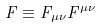Convert formula to latex. <formula><loc_0><loc_0><loc_500><loc_500>F \equiv F _ { \mu \nu } F ^ { \mu \nu }</formula> 